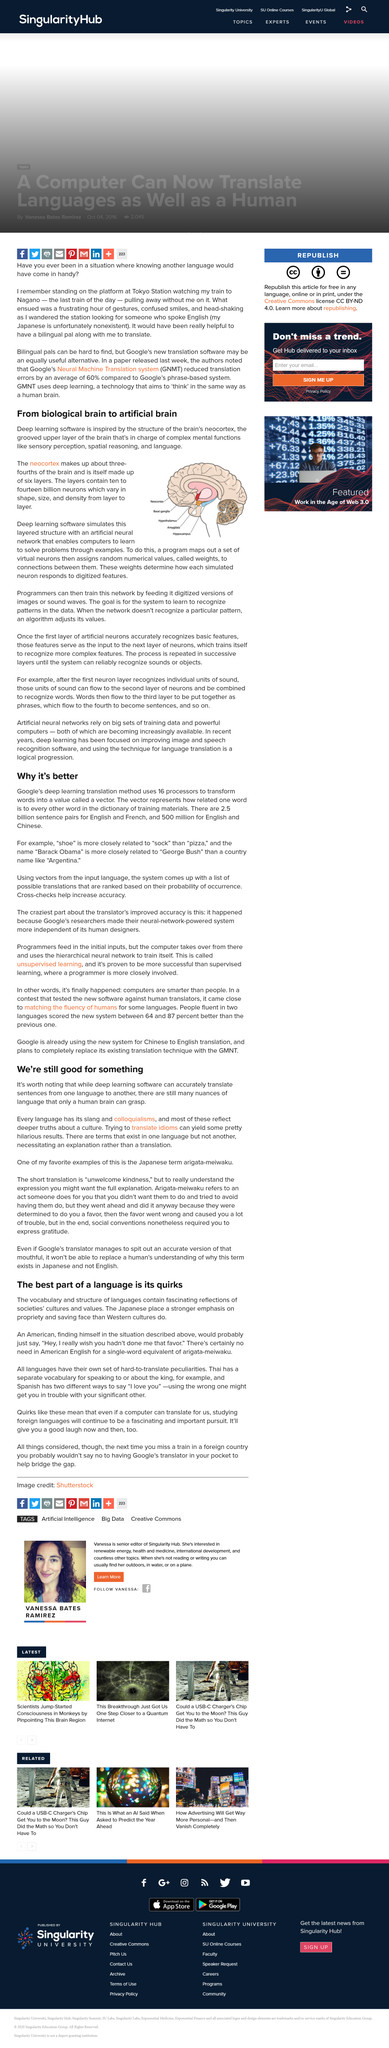Highlight a few significant elements in this photo. Yes, the Thai language has a separate vocabulary for speaking to or about the king. There are approximately 2.5 billion sentence pairs for English and French. The Spanish language offers two distinct ways of expressing the phrase "I love you." What is one of the writer's favorite Japanese terms? It is Arigata-Meiwaku. Arigata meiwaku" is a Japanese phrase that translates to "unwelcome kindness" in English. It refers to a situation where someone offers help or assistance with the intention of being kind, but the recipient of the help feels uncomfortable or unwelcome due to the nature of the offer. 